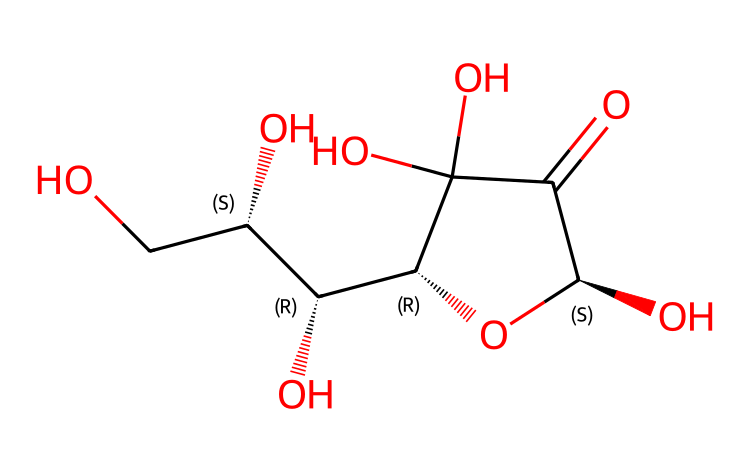how many carbon atoms are in vitamin C? The chemical structure can be analyzed for its carbon atoms. By visual inspection of the SMILES representation, you can count a total of six carbon atoms present in the backbone of the structure.
Answer: six what is the functional group present in vitamin C? The SMILES structure contains hydroxyl (-OH) groups and a carbonyl (C=O) group. The presence of the hydroxyl groups indicates that vitamin C is an alcohol.
Answer: alcohol what role does vitamin C play in ecosystem health? Vitamin C is essential for protecting organisms from oxidative stress due to its antioxidant properties, which is critical for overall ecosystem health. This helps in maintaining biodiversity and the balance of ecosystems.
Answer: antioxidant how many hydroxyl groups are in the vitamin C structure? To determine the number of hydroxyl groups, count the -OH groups in the structure. The SMILES indicates four -OH groups are present in the vitamin C molecule.
Answer: four does vitamin C contain any cyclic structures? The chemical structure of vitamin C includes a cyclic arrangement, specifically there is a cyclic ring formed by one of the carbon chains and oxygen atoms linked together. This is indicative of a lactone structure.
Answer: yes what is the significance of vitamin C for flora and fauna? Vitamin C is crucial for both plants and animals as it aids in physiological functions like growth, repair, and immunity, thus influencing the health of flora and fauna within an ecosystem.
Answer: growth 